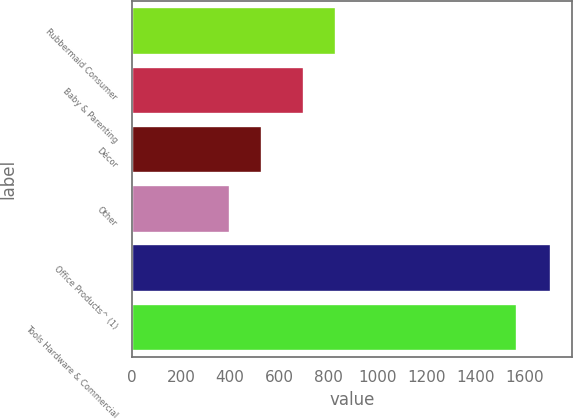Convert chart. <chart><loc_0><loc_0><loc_500><loc_500><bar_chart><fcel>Rubbermaid Consumer<fcel>Baby & Parenting<fcel>Décor<fcel>Other<fcel>Office Products^ (1)<fcel>Tools Hardware & Commercial<nl><fcel>831.12<fcel>700.2<fcel>530.62<fcel>399.7<fcel>1708.9<fcel>1570.9<nl></chart> 